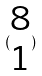Convert formula to latex. <formula><loc_0><loc_0><loc_500><loc_500>( \begin{matrix} 8 \\ 1 \end{matrix} )</formula> 